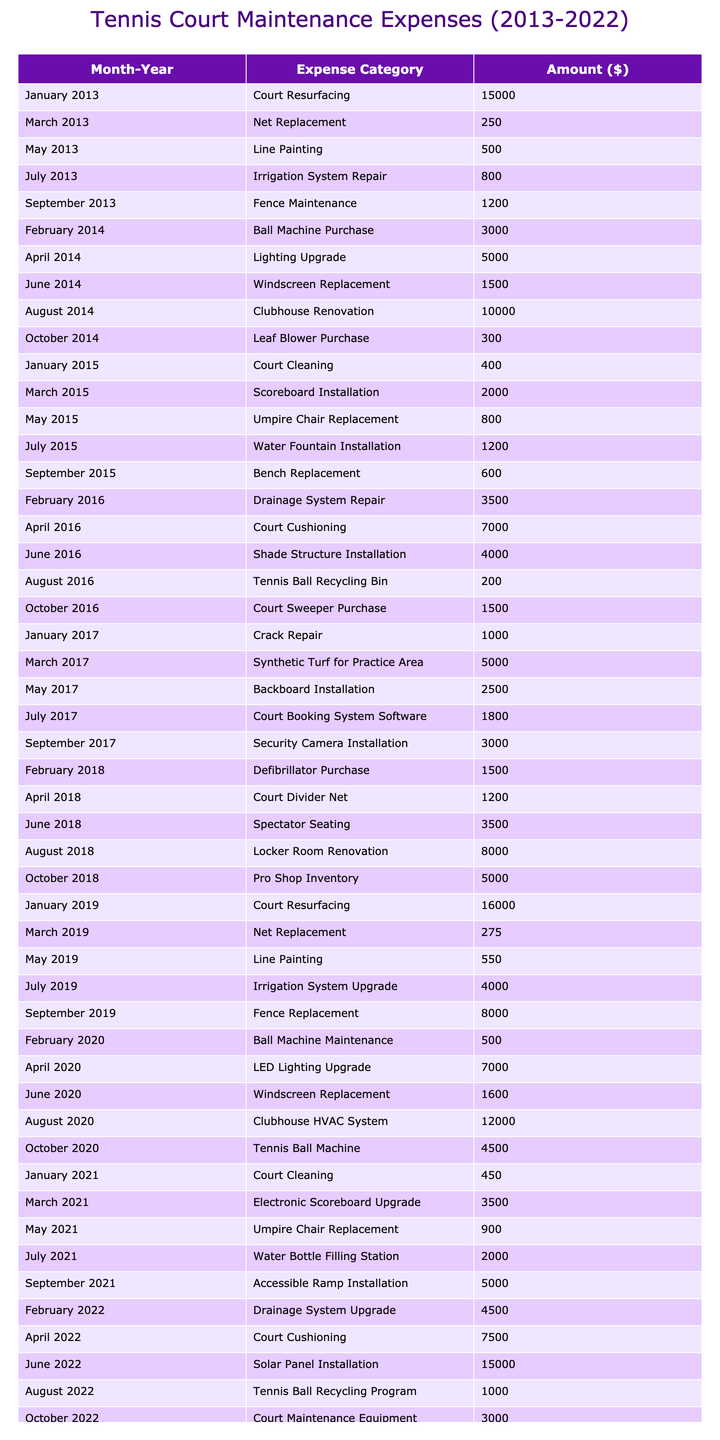What was the total expense for tennis court maintenance in 2013? In 2013, the expenses listed are $15,000 for court resurfacing, $250 for net replacement, $500 for line painting, $800 for irrigation system repair, and $1,200 for fence maintenance. Adding these amounts gives us a total of $15,000 + $250 + $500 + $800 + $1,200 = $17,750.
Answer: $17,750 Which month in 2015 had the highest expense? In 2015, the expenses by month are: January $400, March $2,000, May $800, July $1,200, and September $600. The highest expense was in March with $2,000.
Answer: March What is the average expense for court resurfacing over the decade? The court resurfacing expenses occurred in 2013 ($15,000) and 2019 ($16,000). To find the average, we add these amounts: $15,000 + $16,000 = $31,000 and divide by the number of occurrences, which is 2. So, the average is $31,000/2 = $15,500.
Answer: $15,500 Is the expense for the scoreboard installation higher than the ball machine purchase? The scoreboard installation in 2015 cost $2,000, while the ball machine purchase in 2014 cost $3,000. Since $2,000 is less than $3,000, the statement is false.
Answer: No What was the total expense on irrigation systems from 2013 to 2022? The expenses for irrigation systems are found in 2013 ($800 for repair) and 2019 ($4,000 for upgrade). Adding these amounts gives $800 + $4,000 = $4,800.
Answer: $4,800 Which year had the second highest total maintenance expenses and what was that amount? To find the total for each year, we sum the expenses: 2013: $17,750, 2014: $19,800, 2015: $5,000, 2016: $12,200, 2017: $12,300, 2018: $16,700, 2019: $24,825, 2020: $27,100, 2021: $11,850, 2022: $29,500. The second highest is 2020 with $27,100.
Answer: 2020, $27,100 Was there an expense for court cleaning in both 2015 and 2021? Yes, court cleaning was listed in both 2015 ($400) and 2021 ($450), confirming there were expenses in both years.
Answer: Yes What is the percentage increase in costs from the first year (2013) to the last year (2022)? The total expense in 2013 was $17,750, and in 2022 it was $29,500. The increase is $29,500 - $17,750 = $11,750. The percentage increase is ($11,750 / $17,750) * 100 = 66.14%.
Answer: 66.14% In which month and year was the leaf blower purchased? The leaf blower was purchased in October 2014 for $300. This can be found in the table under the appropriate month and year.
Answer: October 2014 What was the total amount spent on renovations related to the clubhouse over the decade? The clubhouse renovations occurred in 2014 ($10,000 for renovation) and in 2020 ($12,000 for HVAC system). The total spent is $10,000 + $12,000 = $22,000.
Answer: $22,000 Is there any record of expenses for installing a shade structure? If so, when was it? Yes, a shade structure installation was recorded in June 2016 for $4,000.
Answer: Yes, June 2016 